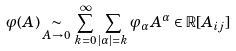<formula> <loc_0><loc_0><loc_500><loc_500>\varphi ( A ) \underset { A \rightarrow 0 } { \sim } \, \sum _ { k = 0 } ^ { \infty } \sum _ { | \alpha | = k } \varphi _ { \alpha } A ^ { \alpha } \in \mathbb { R } [ A _ { i j } ]</formula> 